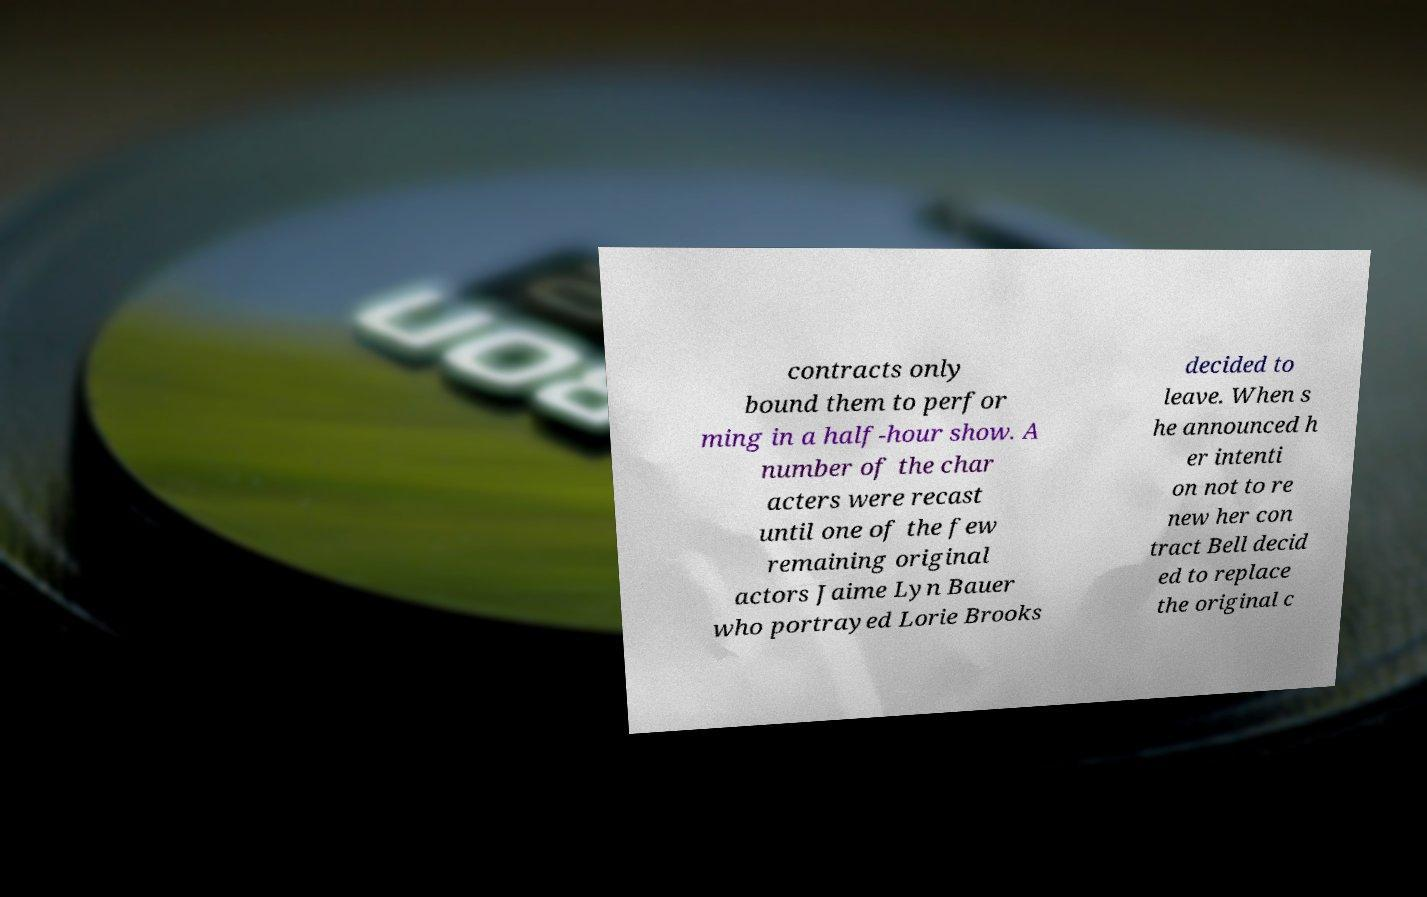Please read and relay the text visible in this image. What does it say? contracts only bound them to perfor ming in a half-hour show. A number of the char acters were recast until one of the few remaining original actors Jaime Lyn Bauer who portrayed Lorie Brooks decided to leave. When s he announced h er intenti on not to re new her con tract Bell decid ed to replace the original c 